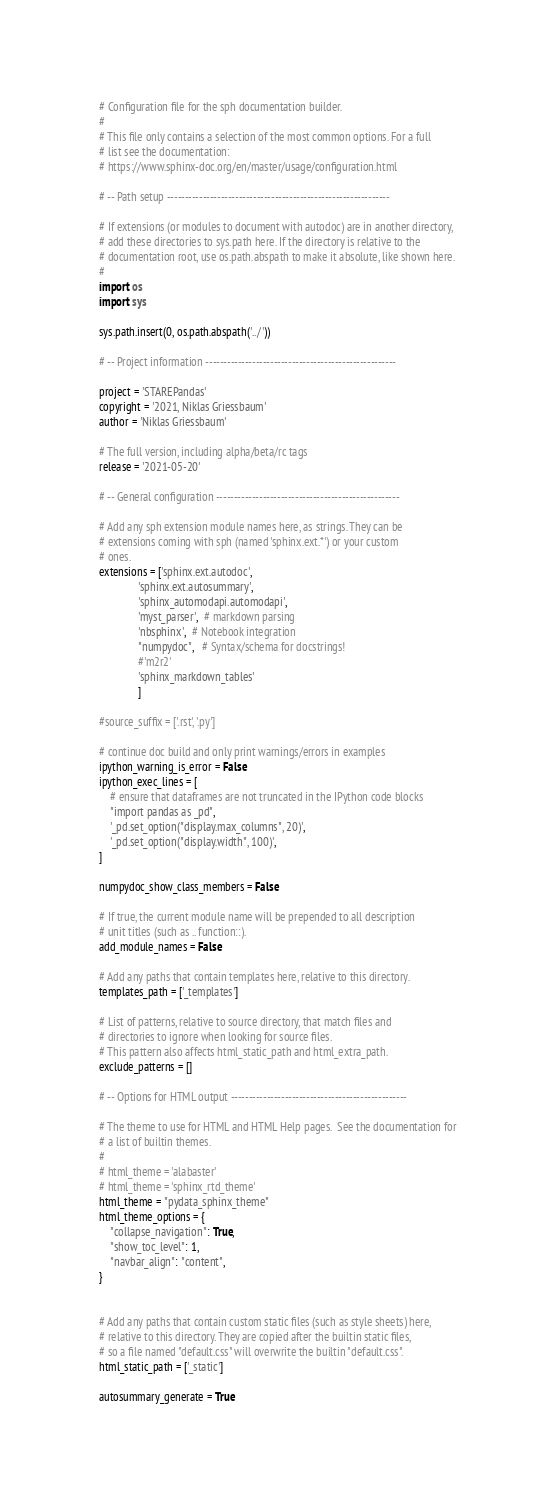<code> <loc_0><loc_0><loc_500><loc_500><_Python_># Configuration file for the sph documentation builder.
#
# This file only contains a selection of the most common options. For a full
# list see the documentation:
# https://www.sphinx-doc.org/en/master/usage/configuration.html

# -- Path setup --------------------------------------------------------------

# If extensions (or modules to document with autodoc) are in another directory,
# add these directories to sys.path here. If the directory is relative to the
# documentation root, use os.path.abspath to make it absolute, like shown here.
#
import os
import sys

sys.path.insert(0, os.path.abspath('../'))

# -- Project information -----------------------------------------------------

project = 'STAREPandas'
copyright = '2021, Niklas Griessbaum'
author = 'Niklas Griessbaum'

# The full version, including alpha/beta/rc tags
release = '2021-05-20'

# -- General configuration ---------------------------------------------------

# Add any sph extension module names here, as strings. They can be
# extensions coming with sph (named 'sphinx.ext.*') or your custom
# ones.
extensions = ['sphinx.ext.autodoc',
              'sphinx.ext.autosummary',
              'sphinx_automodapi.automodapi',
              'myst_parser',  # markdown parsing
              'nbsphinx',  # Notebook integration
              "numpydoc",   # Syntax/schema for docstrings!
              #'m2r2'
              'sphinx_markdown_tables'
              ]

#source_suffix = ['.rst', '.py']

# continue doc build and only print warnings/errors in examples
ipython_warning_is_error = False
ipython_exec_lines = [
    # ensure that dataframes are not truncated in the IPython code blocks
    "import pandas as _pd",
    '_pd.set_option("display.max_columns", 20)',
    '_pd.set_option("display.width", 100)',
]

numpydoc_show_class_members = False

# If true, the current module name will be prepended to all description
# unit titles (such as .. function::).
add_module_names = False

# Add any paths that contain templates here, relative to this directory.
templates_path = ['_templates']

# List of patterns, relative to source directory, that match files and
# directories to ignore when looking for source files.
# This pattern also affects html_static_path and html_extra_path.
exclude_patterns = []

# -- Options for HTML output -------------------------------------------------

# The theme to use for HTML and HTML Help pages.  See the documentation for
# a list of builtin themes.
#
# html_theme = 'alabaster'
# html_theme = 'sphinx_rtd_theme'
html_theme = "pydata_sphinx_theme"
html_theme_options = {
    "collapse_navigation": True,
    "show_toc_level": 1,
    "navbar_align": "content",
}


# Add any paths that contain custom static files (such as style sheets) here,
# relative to this directory. They are copied after the builtin static files,
# so a file named "default.css" will overwrite the builtin "default.css".
html_static_path = ['_static']

autosummary_generate = True
</code> 